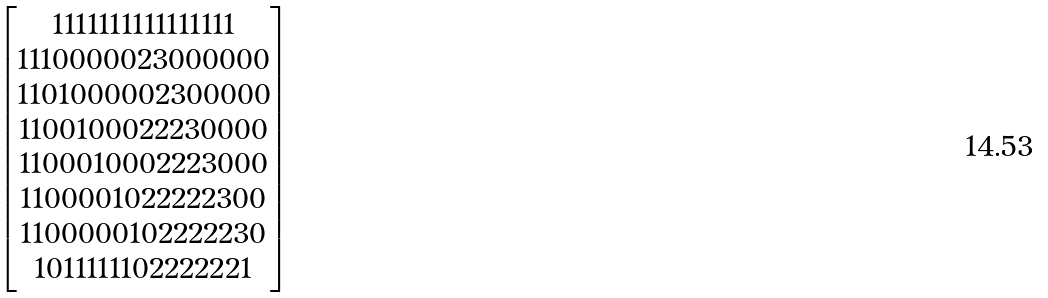Convert formula to latex. <formula><loc_0><loc_0><loc_500><loc_500>\begin{bmatrix} 1 1 1 1 1 1 1 1 1 1 1 1 1 1 1 1 \\ 1 1 1 0 0 0 0 0 2 3 0 0 0 0 0 0 \\ 1 1 0 1 0 0 0 0 0 2 3 0 0 0 0 0 \\ 1 1 0 0 1 0 0 0 2 2 2 3 0 0 0 0 \\ 1 1 0 0 0 1 0 0 0 2 2 2 3 0 0 0 \\ 1 1 0 0 0 0 1 0 2 2 2 2 2 3 0 0 \\ 1 1 0 0 0 0 0 1 0 2 2 2 2 2 3 0 \\ 1 0 1 1 1 1 1 1 0 2 2 2 2 2 2 1 \\ \end{bmatrix}</formula> 